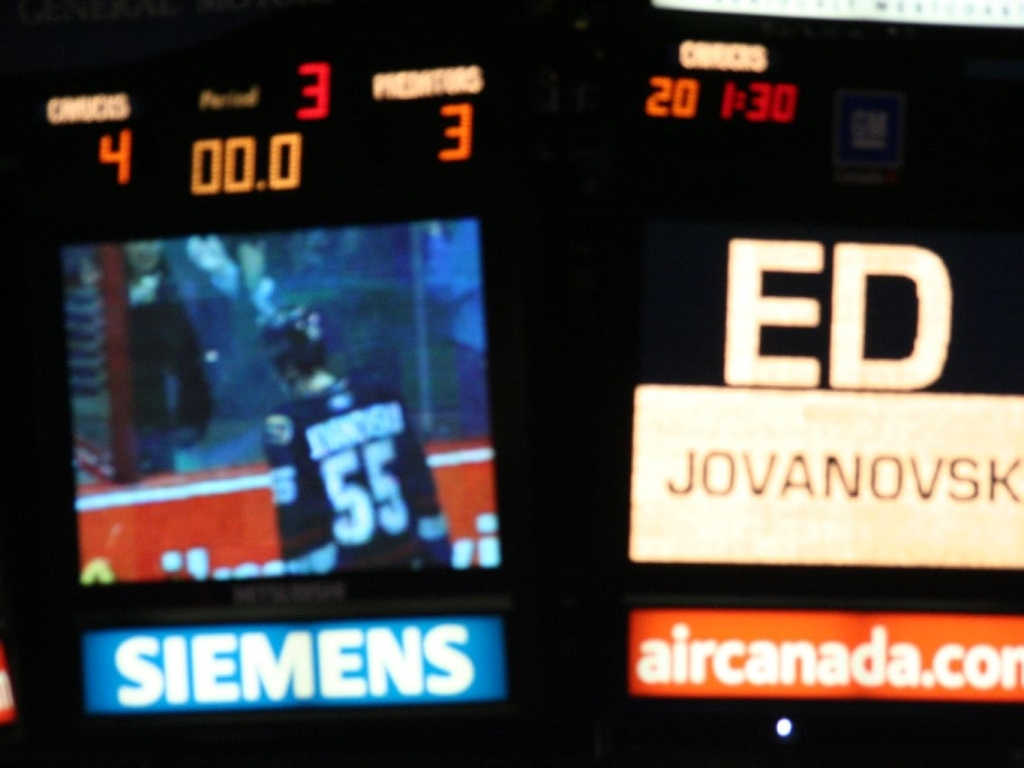Is the composition level average in this image?
A. Yes
B. No While 'average' is somewhat subjective, the composition of the image could be improved for several reasons. Firstly, the subject is not in focus, and the motion blur on the scoreboard suggests camera movement, which detracts from the overall sharpness. Secondly, the framing is off-center, placing the primary subjects awkwardly within the frame. Thirdly, the contrasting bright spots and text elements can distract from the main focus. Therefore, the composition does not meet commonly accepted standards for good quality, which makes the answer B. No. 